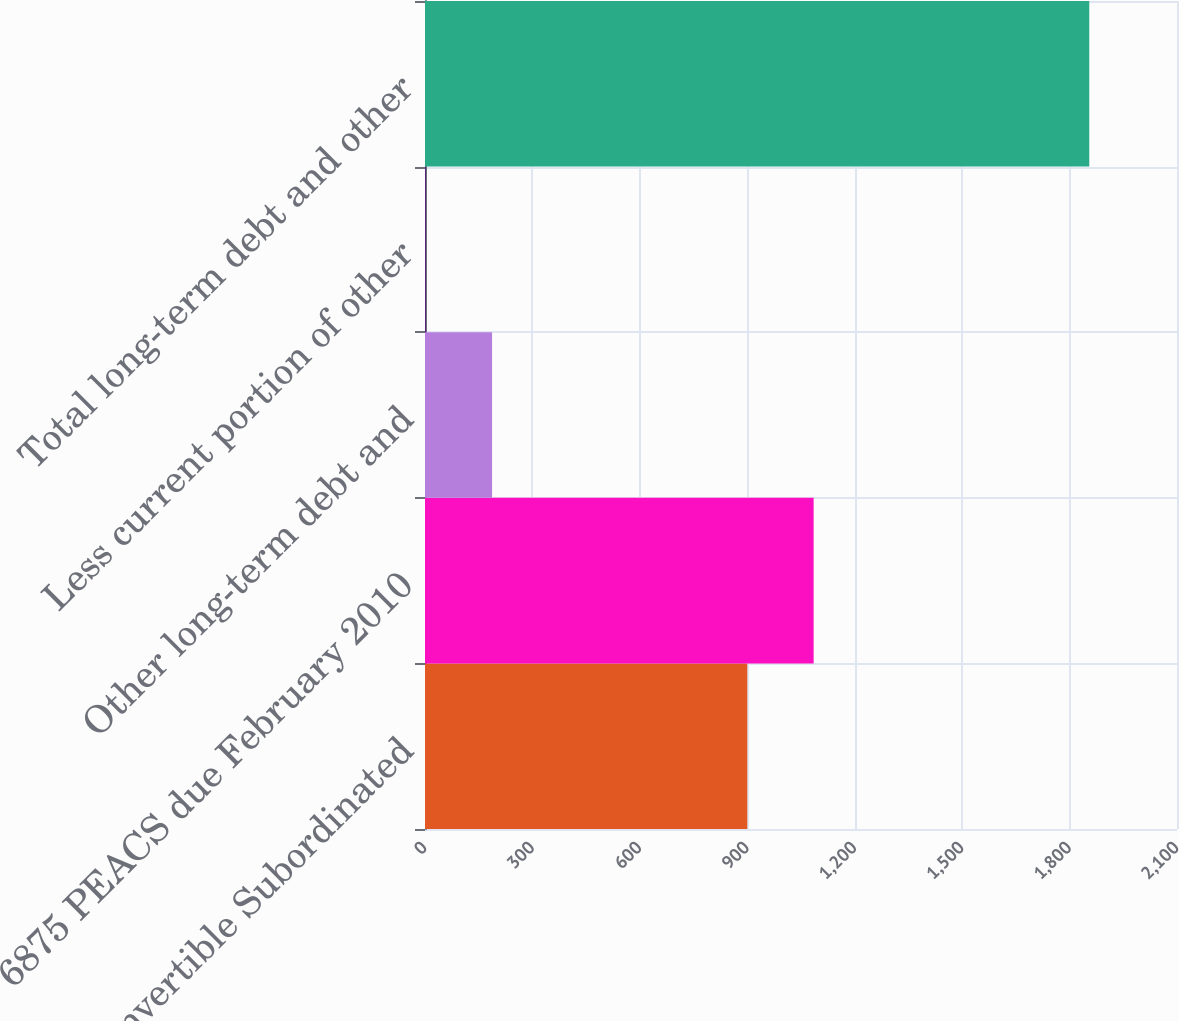Convert chart. <chart><loc_0><loc_0><loc_500><loc_500><bar_chart><fcel>475 Convertible Subordinated<fcel>6875 PEACS due February 2010<fcel>Other long-term debt and<fcel>Less current portion of other<fcel>Total long-term debt and other<nl><fcel>900<fcel>1085.3<fcel>187.3<fcel>2<fcel>1855<nl></chart> 